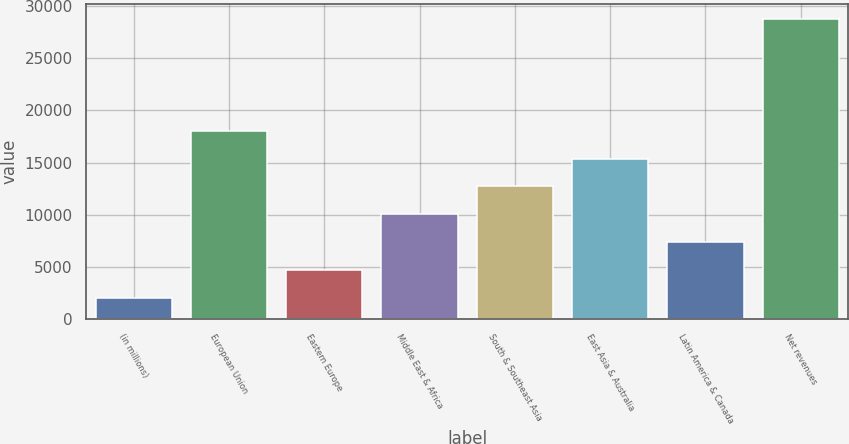<chart> <loc_0><loc_0><loc_500><loc_500><bar_chart><fcel>(in millions)<fcel>European Union<fcel>Eastern Europe<fcel>Middle East & Africa<fcel>South & Southeast Asia<fcel>East Asia & Australia<fcel>Latin America & Canada<fcel>Net revenues<nl><fcel>2017<fcel>18055.6<fcel>4690.1<fcel>10036.3<fcel>12709.4<fcel>15382.5<fcel>7363.2<fcel>28748<nl></chart> 